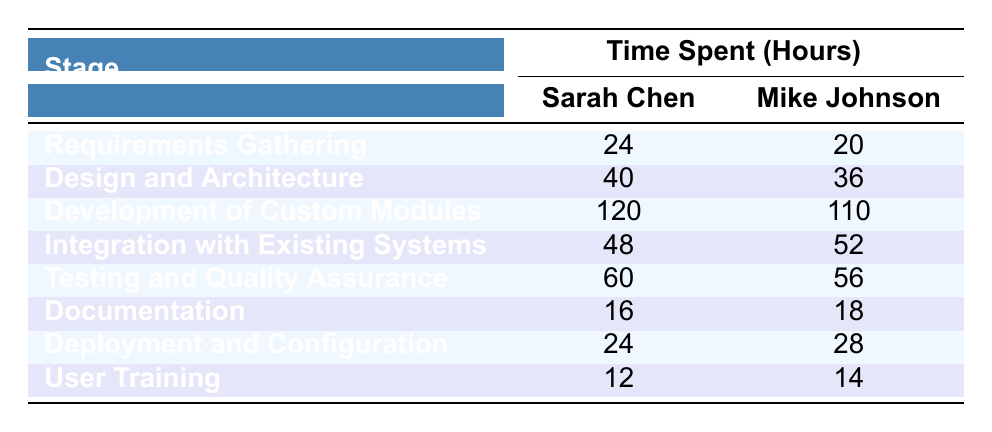What is the time spent on the Development of Custom Modules by Sarah Chen? The table indicates that Sarah Chen spent 120 hours on the Development of Custom Modules, which is explicitly listed under the respective stage.
Answer: 120 hours Which developer spent more time on Integration with Existing Systems? According to the table, Mike Johnson spent 52 hours, while Sarah Chen spent 48 hours on Integration with Existing Systems. Since 52 > 48, Mike Johnson spent more time.
Answer: Mike Johnson What stage had the least total time spent by both developers combined? To find this, we can sum the hours for each stage: Requirements Gathering (44), Design and Architecture (76), Development of Custom Modules (230), Integration with Existing Systems (100), Testing and Quality Assurance (116), Documentation (34), Deployment and Configuration (52), and User Training (26). The stage with the least total hours is User Training with 26 hours.
Answer: User Training Which developer has the maximum time spent across all stages combined? First, we sum each developer's total time: Sarah Chen: 24 + 40 + 120 + 48 + 60 + 16 + 24 + 12 = 344 hours; Mike Johnson: 20 + 36 + 110 + 52 + 56 + 18 + 28 + 14 = 344 hours. Both developers have the same total time spent, thus neither has more time spent.
Answer: Neither What is the average time spent on Testing and Quality Assurance by both developers? By examining the table, Sarah Chen spent 60 hours and Mike Johnson spent 56 hours on Testing and Quality Assurance. The average is calculated as (60 + 56) / 2 = 58 hours.
Answer: 58 hours If we only consider documentation, how much time did Sarah Chen and Mike Johnson spend together? Sarah Chen spent 16 hours on Documentation, and Mike Johnson spent 18 hours. Adding these together gives us 16 + 18 = 34 hours.
Answer: 34 hours Did any developer spend more time on Deployment and Configuration than on User Training? By checking the times, Sarah Chen spent 24 hours on Deployment and Configuration and 12 hours on User Training, while Mike Johnson spent 28 hours and 14 hours respectively. Both developers spent more time on Deployment and Configuration than User Training.
Answer: Yes What is the difference in time spent on Design and Architecture between the two developers? For Design and Architecture, Sarah Chen spent 40 hours and Mike Johnson spent 36 hours. The difference is calculated as 40 - 36 = 4 hours.
Answer: 4 hours Which stage did Sarah Chen spend the most time on? From the table, the maximum time spent by Sarah Chen is 120 hours on the Development of Custom Modules.
Answer: Development of Custom Modules What is the total time spent on Requirements Gathering by both developers? Summing the times, Sarah Chen spent 24 hours and Mike Johnson spent 20 hours, so the total time is 24 + 20 = 44 hours.
Answer: 44 hours 